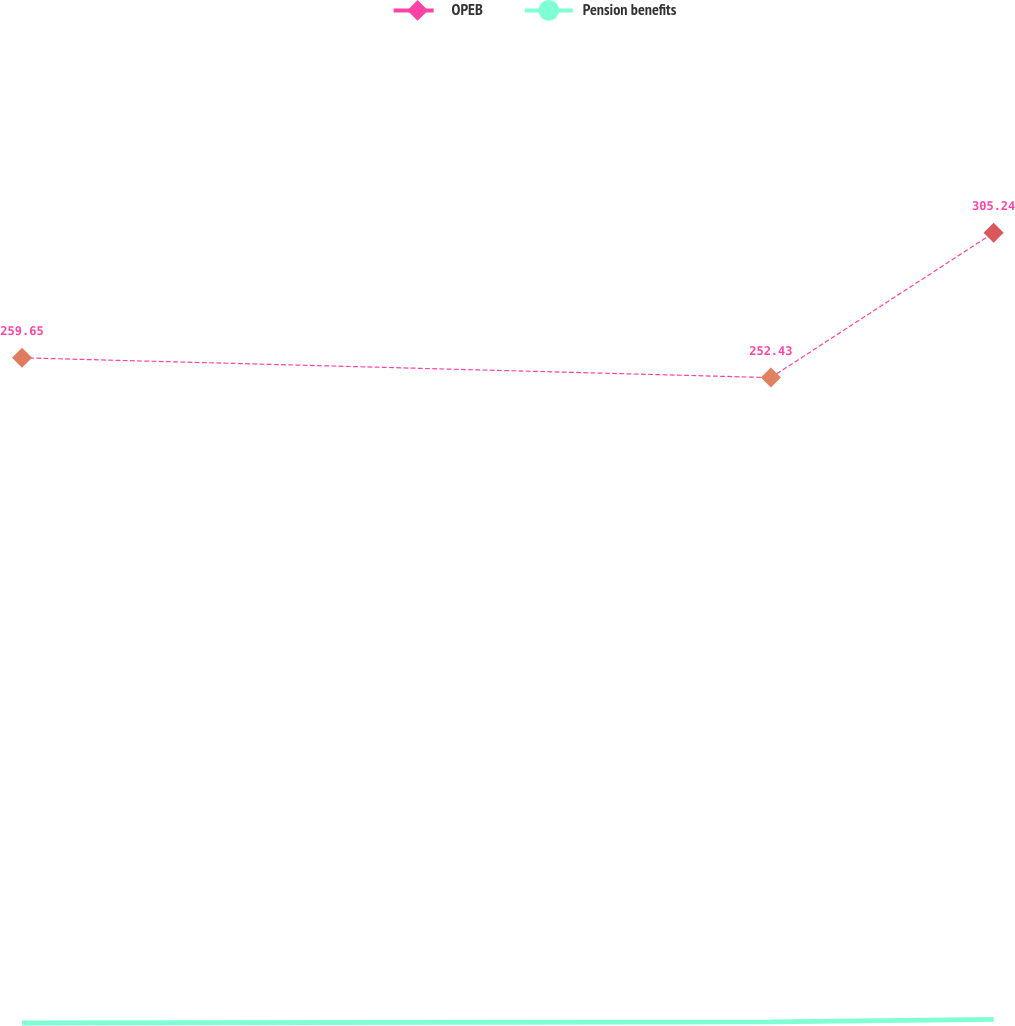Convert chart. <chart><loc_0><loc_0><loc_500><loc_500><line_chart><ecel><fcel>OPEB<fcel>Pension benefits<nl><fcel>1765.54<fcel>259.65<fcel>17.14<nl><fcel>2131.8<fcel>252.43<fcel>17.54<nl><fcel>2240.75<fcel>305.24<fcel>18.48<nl><fcel>2331.79<fcel>276.81<fcel>16.68<nl><fcel>2391.57<fcel>315.79<fcel>19.88<nl></chart> 